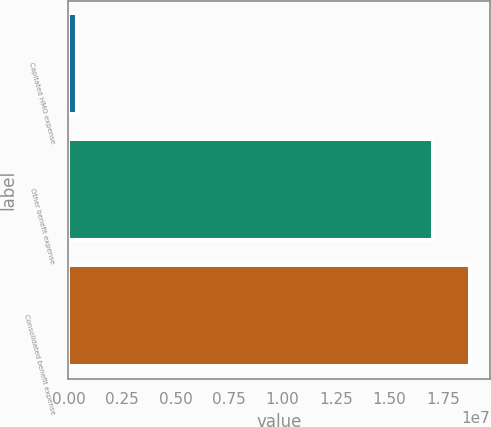Convert chart to OTSL. <chart><loc_0><loc_0><loc_500><loc_500><bar_chart><fcel>Capitated HMO expense<fcel>Other benefit expense<fcel>Consolidated benefit expense<nl><fcel>382584<fcel>1.70386e+07<fcel>1.87425e+07<nl></chart> 